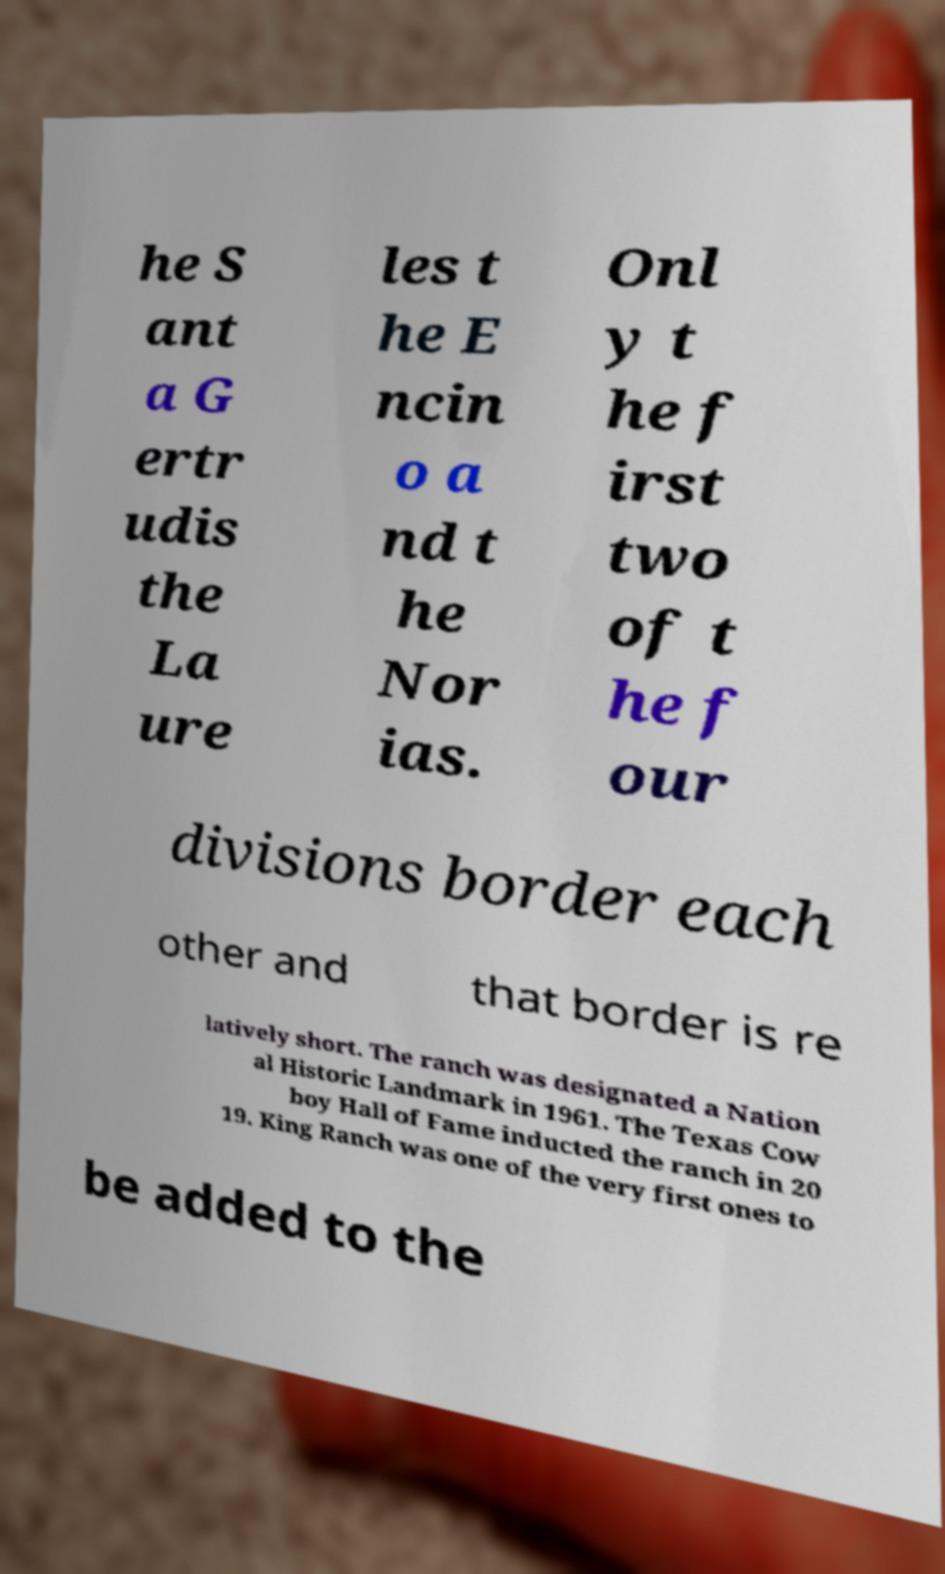What messages or text are displayed in this image? I need them in a readable, typed format. he S ant a G ertr udis the La ure les t he E ncin o a nd t he Nor ias. Onl y t he f irst two of t he f our divisions border each other and that border is re latively short. The ranch was designated a Nation al Historic Landmark in 1961. The Texas Cow boy Hall of Fame inducted the ranch in 20 19. King Ranch was one of the very first ones to be added to the 